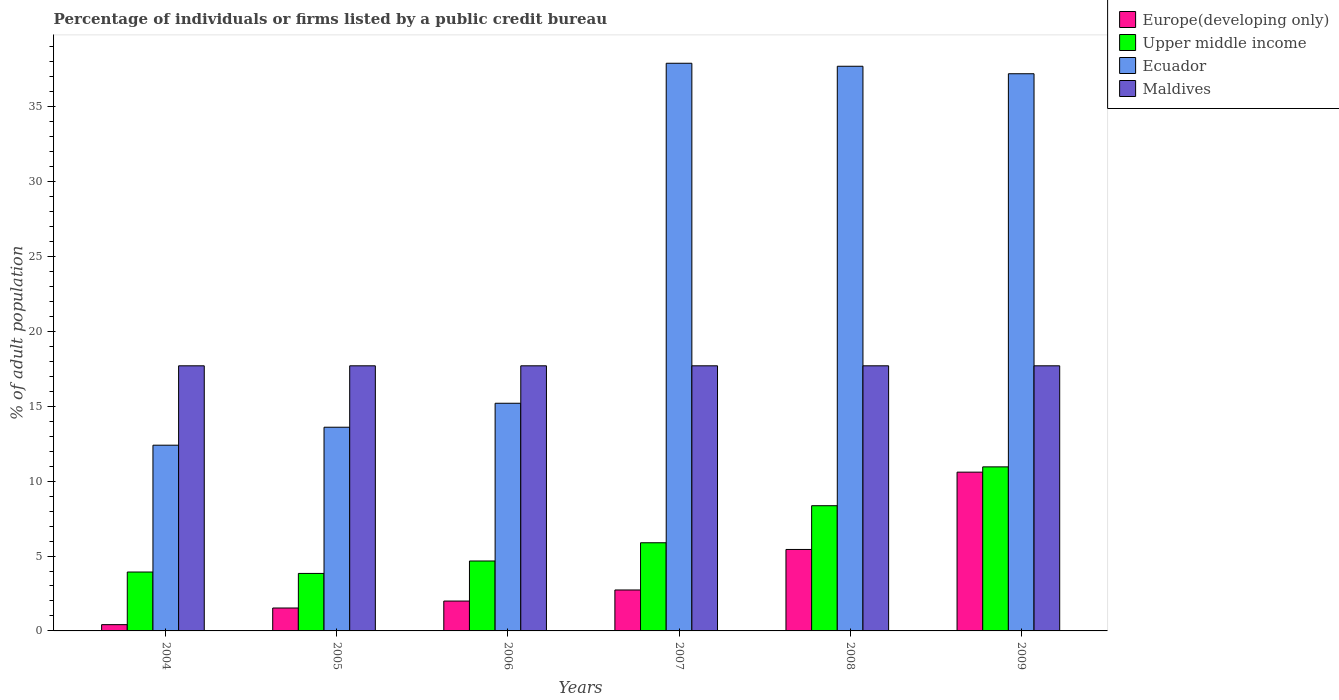How many different coloured bars are there?
Ensure brevity in your answer.  4. How many groups of bars are there?
Offer a very short reply. 6. Are the number of bars per tick equal to the number of legend labels?
Provide a succinct answer. Yes. Are the number of bars on each tick of the X-axis equal?
Your answer should be compact. Yes. What is the percentage of population listed by a public credit bureau in Upper middle income in 2008?
Give a very brief answer. 8.36. Across all years, what is the minimum percentage of population listed by a public credit bureau in Ecuador?
Keep it short and to the point. 12.4. In which year was the percentage of population listed by a public credit bureau in Europe(developing only) maximum?
Make the answer very short. 2009. What is the total percentage of population listed by a public credit bureau in Europe(developing only) in the graph?
Provide a short and direct response. 22.71. What is the difference between the percentage of population listed by a public credit bureau in Upper middle income in 2006 and that in 2007?
Offer a very short reply. -1.22. What is the difference between the percentage of population listed by a public credit bureau in Europe(developing only) in 2007 and the percentage of population listed by a public credit bureau in Ecuador in 2009?
Provide a succinct answer. -34.47. What is the average percentage of population listed by a public credit bureau in Upper middle income per year?
Offer a very short reply. 6.27. In the year 2008, what is the difference between the percentage of population listed by a public credit bureau in Upper middle income and percentage of population listed by a public credit bureau in Europe(developing only)?
Make the answer very short. 2.92. In how many years, is the percentage of population listed by a public credit bureau in Upper middle income greater than 32 %?
Make the answer very short. 0. What is the ratio of the percentage of population listed by a public credit bureau in Ecuador in 2006 to that in 2009?
Your answer should be compact. 0.41. Is the percentage of population listed by a public credit bureau in Ecuador in 2007 less than that in 2009?
Make the answer very short. No. Is the difference between the percentage of population listed by a public credit bureau in Upper middle income in 2007 and 2009 greater than the difference between the percentage of population listed by a public credit bureau in Europe(developing only) in 2007 and 2009?
Keep it short and to the point. Yes. What is the difference between the highest and the second highest percentage of population listed by a public credit bureau in Ecuador?
Provide a succinct answer. 0.2. What is the difference between the highest and the lowest percentage of population listed by a public credit bureau in Upper middle income?
Ensure brevity in your answer.  7.11. In how many years, is the percentage of population listed by a public credit bureau in Ecuador greater than the average percentage of population listed by a public credit bureau in Ecuador taken over all years?
Your answer should be very brief. 3. Is it the case that in every year, the sum of the percentage of population listed by a public credit bureau in Upper middle income and percentage of population listed by a public credit bureau in Europe(developing only) is greater than the sum of percentage of population listed by a public credit bureau in Maldives and percentage of population listed by a public credit bureau in Ecuador?
Your response must be concise. No. What does the 3rd bar from the left in 2009 represents?
Your answer should be very brief. Ecuador. What does the 2nd bar from the right in 2005 represents?
Your answer should be very brief. Ecuador. Is it the case that in every year, the sum of the percentage of population listed by a public credit bureau in Maldives and percentage of population listed by a public credit bureau in Ecuador is greater than the percentage of population listed by a public credit bureau in Europe(developing only)?
Your answer should be very brief. Yes. How many bars are there?
Your answer should be very brief. 24. Are all the bars in the graph horizontal?
Your answer should be very brief. No. How many years are there in the graph?
Ensure brevity in your answer.  6. Does the graph contain grids?
Make the answer very short. No. How are the legend labels stacked?
Ensure brevity in your answer.  Vertical. What is the title of the graph?
Offer a very short reply. Percentage of individuals or firms listed by a public credit bureau. What is the label or title of the X-axis?
Your answer should be very brief. Years. What is the label or title of the Y-axis?
Make the answer very short. % of adult population. What is the % of adult population in Europe(developing only) in 2004?
Provide a succinct answer. 0.42. What is the % of adult population in Upper middle income in 2004?
Make the answer very short. 3.93. What is the % of adult population in Maldives in 2004?
Provide a short and direct response. 17.7. What is the % of adult population of Europe(developing only) in 2005?
Keep it short and to the point. 1.53. What is the % of adult population in Upper middle income in 2005?
Provide a short and direct response. 3.84. What is the % of adult population of Ecuador in 2005?
Provide a short and direct response. 13.6. What is the % of adult population of Europe(developing only) in 2006?
Ensure brevity in your answer.  1.99. What is the % of adult population of Upper middle income in 2006?
Your answer should be compact. 4.67. What is the % of adult population of Ecuador in 2006?
Ensure brevity in your answer.  15.2. What is the % of adult population of Maldives in 2006?
Your answer should be very brief. 17.7. What is the % of adult population in Europe(developing only) in 2007?
Keep it short and to the point. 2.73. What is the % of adult population of Upper middle income in 2007?
Your answer should be very brief. 5.89. What is the % of adult population in Ecuador in 2007?
Ensure brevity in your answer.  37.9. What is the % of adult population in Europe(developing only) in 2008?
Provide a succinct answer. 5.44. What is the % of adult population of Upper middle income in 2008?
Give a very brief answer. 8.36. What is the % of adult population in Ecuador in 2008?
Keep it short and to the point. 37.7. What is the % of adult population of Upper middle income in 2009?
Provide a succinct answer. 10.95. What is the % of adult population in Ecuador in 2009?
Provide a succinct answer. 37.2. What is the % of adult population of Maldives in 2009?
Offer a very short reply. 17.7. Across all years, what is the maximum % of adult population in Europe(developing only)?
Your answer should be very brief. 10.6. Across all years, what is the maximum % of adult population in Upper middle income?
Provide a succinct answer. 10.95. Across all years, what is the maximum % of adult population in Ecuador?
Your answer should be very brief. 37.9. Across all years, what is the maximum % of adult population of Maldives?
Offer a very short reply. 17.7. Across all years, what is the minimum % of adult population in Europe(developing only)?
Your answer should be very brief. 0.42. Across all years, what is the minimum % of adult population in Upper middle income?
Your answer should be compact. 3.84. Across all years, what is the minimum % of adult population in Ecuador?
Your response must be concise. 12.4. What is the total % of adult population in Europe(developing only) in the graph?
Ensure brevity in your answer.  22.71. What is the total % of adult population in Upper middle income in the graph?
Provide a short and direct response. 37.64. What is the total % of adult population in Ecuador in the graph?
Make the answer very short. 154. What is the total % of adult population in Maldives in the graph?
Offer a very short reply. 106.2. What is the difference between the % of adult population in Europe(developing only) in 2004 and that in 2005?
Offer a very short reply. -1.11. What is the difference between the % of adult population in Upper middle income in 2004 and that in 2005?
Ensure brevity in your answer.  0.09. What is the difference between the % of adult population in Ecuador in 2004 and that in 2005?
Give a very brief answer. -1.2. What is the difference between the % of adult population in Maldives in 2004 and that in 2005?
Your response must be concise. 0. What is the difference between the % of adult population in Europe(developing only) in 2004 and that in 2006?
Keep it short and to the point. -1.58. What is the difference between the % of adult population of Upper middle income in 2004 and that in 2006?
Provide a succinct answer. -0.74. What is the difference between the % of adult population of Ecuador in 2004 and that in 2006?
Give a very brief answer. -2.8. What is the difference between the % of adult population of Europe(developing only) in 2004 and that in 2007?
Offer a terse response. -2.31. What is the difference between the % of adult population in Upper middle income in 2004 and that in 2007?
Provide a short and direct response. -1.95. What is the difference between the % of adult population in Ecuador in 2004 and that in 2007?
Give a very brief answer. -25.5. What is the difference between the % of adult population in Europe(developing only) in 2004 and that in 2008?
Offer a very short reply. -5.02. What is the difference between the % of adult population in Upper middle income in 2004 and that in 2008?
Provide a short and direct response. -4.43. What is the difference between the % of adult population in Ecuador in 2004 and that in 2008?
Offer a very short reply. -25.3. What is the difference between the % of adult population in Maldives in 2004 and that in 2008?
Give a very brief answer. 0. What is the difference between the % of adult population of Europe(developing only) in 2004 and that in 2009?
Provide a short and direct response. -10.18. What is the difference between the % of adult population in Upper middle income in 2004 and that in 2009?
Provide a succinct answer. -7.02. What is the difference between the % of adult population of Ecuador in 2004 and that in 2009?
Provide a short and direct response. -24.8. What is the difference between the % of adult population in Europe(developing only) in 2005 and that in 2006?
Offer a terse response. -0.47. What is the difference between the % of adult population in Upper middle income in 2005 and that in 2006?
Ensure brevity in your answer.  -0.83. What is the difference between the % of adult population in Maldives in 2005 and that in 2006?
Make the answer very short. 0. What is the difference between the % of adult population in Europe(developing only) in 2005 and that in 2007?
Your answer should be compact. -1.2. What is the difference between the % of adult population in Upper middle income in 2005 and that in 2007?
Ensure brevity in your answer.  -2.05. What is the difference between the % of adult population of Ecuador in 2005 and that in 2007?
Provide a succinct answer. -24.3. What is the difference between the % of adult population in Europe(developing only) in 2005 and that in 2008?
Make the answer very short. -3.91. What is the difference between the % of adult population of Upper middle income in 2005 and that in 2008?
Ensure brevity in your answer.  -4.52. What is the difference between the % of adult population of Ecuador in 2005 and that in 2008?
Make the answer very short. -24.1. What is the difference between the % of adult population of Maldives in 2005 and that in 2008?
Make the answer very short. 0. What is the difference between the % of adult population in Europe(developing only) in 2005 and that in 2009?
Your response must be concise. -9.07. What is the difference between the % of adult population in Upper middle income in 2005 and that in 2009?
Give a very brief answer. -7.11. What is the difference between the % of adult population in Ecuador in 2005 and that in 2009?
Give a very brief answer. -23.6. What is the difference between the % of adult population in Maldives in 2005 and that in 2009?
Keep it short and to the point. 0. What is the difference between the % of adult population in Europe(developing only) in 2006 and that in 2007?
Ensure brevity in your answer.  -0.74. What is the difference between the % of adult population of Upper middle income in 2006 and that in 2007?
Give a very brief answer. -1.22. What is the difference between the % of adult population in Ecuador in 2006 and that in 2007?
Provide a succinct answer. -22.7. What is the difference between the % of adult population in Europe(developing only) in 2006 and that in 2008?
Ensure brevity in your answer.  -3.44. What is the difference between the % of adult population in Upper middle income in 2006 and that in 2008?
Keep it short and to the point. -3.69. What is the difference between the % of adult population in Ecuador in 2006 and that in 2008?
Your answer should be very brief. -22.5. What is the difference between the % of adult population in Europe(developing only) in 2006 and that in 2009?
Offer a very short reply. -8.61. What is the difference between the % of adult population of Upper middle income in 2006 and that in 2009?
Give a very brief answer. -6.28. What is the difference between the % of adult population of Ecuador in 2006 and that in 2009?
Your answer should be compact. -22. What is the difference between the % of adult population of Maldives in 2006 and that in 2009?
Your response must be concise. 0. What is the difference between the % of adult population in Europe(developing only) in 2007 and that in 2008?
Your response must be concise. -2.71. What is the difference between the % of adult population of Upper middle income in 2007 and that in 2008?
Ensure brevity in your answer.  -2.47. What is the difference between the % of adult population of Ecuador in 2007 and that in 2008?
Provide a succinct answer. 0.2. What is the difference between the % of adult population of Europe(developing only) in 2007 and that in 2009?
Your response must be concise. -7.87. What is the difference between the % of adult population in Upper middle income in 2007 and that in 2009?
Your answer should be compact. -5.07. What is the difference between the % of adult population in Europe(developing only) in 2008 and that in 2009?
Offer a very short reply. -5.16. What is the difference between the % of adult population of Upper middle income in 2008 and that in 2009?
Make the answer very short. -2.59. What is the difference between the % of adult population in Maldives in 2008 and that in 2009?
Offer a very short reply. 0. What is the difference between the % of adult population of Europe(developing only) in 2004 and the % of adult population of Upper middle income in 2005?
Ensure brevity in your answer.  -3.42. What is the difference between the % of adult population in Europe(developing only) in 2004 and the % of adult population in Ecuador in 2005?
Your response must be concise. -13.18. What is the difference between the % of adult population of Europe(developing only) in 2004 and the % of adult population of Maldives in 2005?
Your response must be concise. -17.28. What is the difference between the % of adult population in Upper middle income in 2004 and the % of adult population in Ecuador in 2005?
Keep it short and to the point. -9.67. What is the difference between the % of adult population of Upper middle income in 2004 and the % of adult population of Maldives in 2005?
Your answer should be very brief. -13.77. What is the difference between the % of adult population in Ecuador in 2004 and the % of adult population in Maldives in 2005?
Make the answer very short. -5.3. What is the difference between the % of adult population of Europe(developing only) in 2004 and the % of adult population of Upper middle income in 2006?
Your answer should be very brief. -4.25. What is the difference between the % of adult population in Europe(developing only) in 2004 and the % of adult population in Ecuador in 2006?
Offer a very short reply. -14.78. What is the difference between the % of adult population in Europe(developing only) in 2004 and the % of adult population in Maldives in 2006?
Provide a short and direct response. -17.28. What is the difference between the % of adult population of Upper middle income in 2004 and the % of adult population of Ecuador in 2006?
Your answer should be very brief. -11.27. What is the difference between the % of adult population of Upper middle income in 2004 and the % of adult population of Maldives in 2006?
Give a very brief answer. -13.77. What is the difference between the % of adult population of Europe(developing only) in 2004 and the % of adult population of Upper middle income in 2007?
Your answer should be compact. -5.47. What is the difference between the % of adult population of Europe(developing only) in 2004 and the % of adult population of Ecuador in 2007?
Provide a short and direct response. -37.48. What is the difference between the % of adult population in Europe(developing only) in 2004 and the % of adult population in Maldives in 2007?
Your answer should be compact. -17.28. What is the difference between the % of adult population of Upper middle income in 2004 and the % of adult population of Ecuador in 2007?
Offer a terse response. -33.97. What is the difference between the % of adult population in Upper middle income in 2004 and the % of adult population in Maldives in 2007?
Offer a very short reply. -13.77. What is the difference between the % of adult population in Ecuador in 2004 and the % of adult population in Maldives in 2007?
Offer a terse response. -5.3. What is the difference between the % of adult population of Europe(developing only) in 2004 and the % of adult population of Upper middle income in 2008?
Ensure brevity in your answer.  -7.94. What is the difference between the % of adult population in Europe(developing only) in 2004 and the % of adult population in Ecuador in 2008?
Provide a short and direct response. -37.28. What is the difference between the % of adult population in Europe(developing only) in 2004 and the % of adult population in Maldives in 2008?
Ensure brevity in your answer.  -17.28. What is the difference between the % of adult population of Upper middle income in 2004 and the % of adult population of Ecuador in 2008?
Provide a succinct answer. -33.77. What is the difference between the % of adult population of Upper middle income in 2004 and the % of adult population of Maldives in 2008?
Make the answer very short. -13.77. What is the difference between the % of adult population of Europe(developing only) in 2004 and the % of adult population of Upper middle income in 2009?
Give a very brief answer. -10.53. What is the difference between the % of adult population in Europe(developing only) in 2004 and the % of adult population in Ecuador in 2009?
Offer a terse response. -36.78. What is the difference between the % of adult population of Europe(developing only) in 2004 and the % of adult population of Maldives in 2009?
Your response must be concise. -17.28. What is the difference between the % of adult population in Upper middle income in 2004 and the % of adult population in Ecuador in 2009?
Your answer should be compact. -33.27. What is the difference between the % of adult population in Upper middle income in 2004 and the % of adult population in Maldives in 2009?
Offer a very short reply. -13.77. What is the difference between the % of adult population of Ecuador in 2004 and the % of adult population of Maldives in 2009?
Provide a succinct answer. -5.3. What is the difference between the % of adult population in Europe(developing only) in 2005 and the % of adult population in Upper middle income in 2006?
Offer a terse response. -3.14. What is the difference between the % of adult population of Europe(developing only) in 2005 and the % of adult population of Ecuador in 2006?
Ensure brevity in your answer.  -13.67. What is the difference between the % of adult population of Europe(developing only) in 2005 and the % of adult population of Maldives in 2006?
Provide a succinct answer. -16.17. What is the difference between the % of adult population in Upper middle income in 2005 and the % of adult population in Ecuador in 2006?
Give a very brief answer. -11.36. What is the difference between the % of adult population in Upper middle income in 2005 and the % of adult population in Maldives in 2006?
Provide a short and direct response. -13.86. What is the difference between the % of adult population of Ecuador in 2005 and the % of adult population of Maldives in 2006?
Offer a terse response. -4.1. What is the difference between the % of adult population of Europe(developing only) in 2005 and the % of adult population of Upper middle income in 2007?
Your answer should be compact. -4.36. What is the difference between the % of adult population in Europe(developing only) in 2005 and the % of adult population in Ecuador in 2007?
Offer a terse response. -36.37. What is the difference between the % of adult population of Europe(developing only) in 2005 and the % of adult population of Maldives in 2007?
Ensure brevity in your answer.  -16.17. What is the difference between the % of adult population in Upper middle income in 2005 and the % of adult population in Ecuador in 2007?
Ensure brevity in your answer.  -34.06. What is the difference between the % of adult population in Upper middle income in 2005 and the % of adult population in Maldives in 2007?
Keep it short and to the point. -13.86. What is the difference between the % of adult population in Europe(developing only) in 2005 and the % of adult population in Upper middle income in 2008?
Keep it short and to the point. -6.83. What is the difference between the % of adult population of Europe(developing only) in 2005 and the % of adult population of Ecuador in 2008?
Give a very brief answer. -36.17. What is the difference between the % of adult population in Europe(developing only) in 2005 and the % of adult population in Maldives in 2008?
Ensure brevity in your answer.  -16.17. What is the difference between the % of adult population of Upper middle income in 2005 and the % of adult population of Ecuador in 2008?
Provide a succinct answer. -33.86. What is the difference between the % of adult population of Upper middle income in 2005 and the % of adult population of Maldives in 2008?
Your answer should be compact. -13.86. What is the difference between the % of adult population in Ecuador in 2005 and the % of adult population in Maldives in 2008?
Make the answer very short. -4.1. What is the difference between the % of adult population of Europe(developing only) in 2005 and the % of adult population of Upper middle income in 2009?
Ensure brevity in your answer.  -9.42. What is the difference between the % of adult population of Europe(developing only) in 2005 and the % of adult population of Ecuador in 2009?
Offer a terse response. -35.67. What is the difference between the % of adult population in Europe(developing only) in 2005 and the % of adult population in Maldives in 2009?
Provide a succinct answer. -16.17. What is the difference between the % of adult population of Upper middle income in 2005 and the % of adult population of Ecuador in 2009?
Make the answer very short. -33.36. What is the difference between the % of adult population of Upper middle income in 2005 and the % of adult population of Maldives in 2009?
Keep it short and to the point. -13.86. What is the difference between the % of adult population of Ecuador in 2005 and the % of adult population of Maldives in 2009?
Offer a terse response. -4.1. What is the difference between the % of adult population of Europe(developing only) in 2006 and the % of adult population of Upper middle income in 2007?
Give a very brief answer. -3.89. What is the difference between the % of adult population of Europe(developing only) in 2006 and the % of adult population of Ecuador in 2007?
Ensure brevity in your answer.  -35.91. What is the difference between the % of adult population of Europe(developing only) in 2006 and the % of adult population of Maldives in 2007?
Ensure brevity in your answer.  -15.71. What is the difference between the % of adult population of Upper middle income in 2006 and the % of adult population of Ecuador in 2007?
Your answer should be compact. -33.23. What is the difference between the % of adult population of Upper middle income in 2006 and the % of adult population of Maldives in 2007?
Make the answer very short. -13.03. What is the difference between the % of adult population of Europe(developing only) in 2006 and the % of adult population of Upper middle income in 2008?
Ensure brevity in your answer.  -6.37. What is the difference between the % of adult population of Europe(developing only) in 2006 and the % of adult population of Ecuador in 2008?
Provide a succinct answer. -35.71. What is the difference between the % of adult population of Europe(developing only) in 2006 and the % of adult population of Maldives in 2008?
Your response must be concise. -15.71. What is the difference between the % of adult population in Upper middle income in 2006 and the % of adult population in Ecuador in 2008?
Keep it short and to the point. -33.03. What is the difference between the % of adult population of Upper middle income in 2006 and the % of adult population of Maldives in 2008?
Provide a short and direct response. -13.03. What is the difference between the % of adult population of Europe(developing only) in 2006 and the % of adult population of Upper middle income in 2009?
Make the answer very short. -8.96. What is the difference between the % of adult population of Europe(developing only) in 2006 and the % of adult population of Ecuador in 2009?
Offer a very short reply. -35.21. What is the difference between the % of adult population in Europe(developing only) in 2006 and the % of adult population in Maldives in 2009?
Offer a terse response. -15.71. What is the difference between the % of adult population of Upper middle income in 2006 and the % of adult population of Ecuador in 2009?
Your answer should be compact. -32.53. What is the difference between the % of adult population of Upper middle income in 2006 and the % of adult population of Maldives in 2009?
Your answer should be compact. -13.03. What is the difference between the % of adult population in Ecuador in 2006 and the % of adult population in Maldives in 2009?
Your answer should be compact. -2.5. What is the difference between the % of adult population in Europe(developing only) in 2007 and the % of adult population in Upper middle income in 2008?
Your answer should be very brief. -5.63. What is the difference between the % of adult population in Europe(developing only) in 2007 and the % of adult population in Ecuador in 2008?
Your response must be concise. -34.97. What is the difference between the % of adult population in Europe(developing only) in 2007 and the % of adult population in Maldives in 2008?
Ensure brevity in your answer.  -14.97. What is the difference between the % of adult population of Upper middle income in 2007 and the % of adult population of Ecuador in 2008?
Your answer should be compact. -31.81. What is the difference between the % of adult population of Upper middle income in 2007 and the % of adult population of Maldives in 2008?
Provide a short and direct response. -11.81. What is the difference between the % of adult population of Ecuador in 2007 and the % of adult population of Maldives in 2008?
Your answer should be very brief. 20.2. What is the difference between the % of adult population of Europe(developing only) in 2007 and the % of adult population of Upper middle income in 2009?
Offer a very short reply. -8.22. What is the difference between the % of adult population in Europe(developing only) in 2007 and the % of adult population in Ecuador in 2009?
Make the answer very short. -34.47. What is the difference between the % of adult population of Europe(developing only) in 2007 and the % of adult population of Maldives in 2009?
Your response must be concise. -14.97. What is the difference between the % of adult population of Upper middle income in 2007 and the % of adult population of Ecuador in 2009?
Offer a very short reply. -31.31. What is the difference between the % of adult population in Upper middle income in 2007 and the % of adult population in Maldives in 2009?
Keep it short and to the point. -11.81. What is the difference between the % of adult population in Ecuador in 2007 and the % of adult population in Maldives in 2009?
Provide a succinct answer. 20.2. What is the difference between the % of adult population in Europe(developing only) in 2008 and the % of adult population in Upper middle income in 2009?
Keep it short and to the point. -5.51. What is the difference between the % of adult population of Europe(developing only) in 2008 and the % of adult population of Ecuador in 2009?
Give a very brief answer. -31.76. What is the difference between the % of adult population in Europe(developing only) in 2008 and the % of adult population in Maldives in 2009?
Your answer should be compact. -12.26. What is the difference between the % of adult population in Upper middle income in 2008 and the % of adult population in Ecuador in 2009?
Your answer should be very brief. -28.84. What is the difference between the % of adult population of Upper middle income in 2008 and the % of adult population of Maldives in 2009?
Offer a very short reply. -9.34. What is the average % of adult population in Europe(developing only) per year?
Make the answer very short. 3.79. What is the average % of adult population in Upper middle income per year?
Provide a short and direct response. 6.27. What is the average % of adult population of Ecuador per year?
Give a very brief answer. 25.67. What is the average % of adult population of Maldives per year?
Provide a short and direct response. 17.7. In the year 2004, what is the difference between the % of adult population in Europe(developing only) and % of adult population in Upper middle income?
Offer a terse response. -3.51. In the year 2004, what is the difference between the % of adult population of Europe(developing only) and % of adult population of Ecuador?
Provide a short and direct response. -11.98. In the year 2004, what is the difference between the % of adult population in Europe(developing only) and % of adult population in Maldives?
Your response must be concise. -17.28. In the year 2004, what is the difference between the % of adult population in Upper middle income and % of adult population in Ecuador?
Your response must be concise. -8.47. In the year 2004, what is the difference between the % of adult population in Upper middle income and % of adult population in Maldives?
Provide a succinct answer. -13.77. In the year 2005, what is the difference between the % of adult population of Europe(developing only) and % of adult population of Upper middle income?
Keep it short and to the point. -2.31. In the year 2005, what is the difference between the % of adult population in Europe(developing only) and % of adult population in Ecuador?
Ensure brevity in your answer.  -12.07. In the year 2005, what is the difference between the % of adult population in Europe(developing only) and % of adult population in Maldives?
Make the answer very short. -16.17. In the year 2005, what is the difference between the % of adult population in Upper middle income and % of adult population in Ecuador?
Offer a terse response. -9.76. In the year 2005, what is the difference between the % of adult population in Upper middle income and % of adult population in Maldives?
Provide a short and direct response. -13.86. In the year 2005, what is the difference between the % of adult population of Ecuador and % of adult population of Maldives?
Give a very brief answer. -4.1. In the year 2006, what is the difference between the % of adult population in Europe(developing only) and % of adult population in Upper middle income?
Ensure brevity in your answer.  -2.67. In the year 2006, what is the difference between the % of adult population in Europe(developing only) and % of adult population in Ecuador?
Your answer should be very brief. -13.21. In the year 2006, what is the difference between the % of adult population of Europe(developing only) and % of adult population of Maldives?
Give a very brief answer. -15.71. In the year 2006, what is the difference between the % of adult population in Upper middle income and % of adult population in Ecuador?
Offer a terse response. -10.53. In the year 2006, what is the difference between the % of adult population in Upper middle income and % of adult population in Maldives?
Provide a short and direct response. -13.03. In the year 2006, what is the difference between the % of adult population of Ecuador and % of adult population of Maldives?
Keep it short and to the point. -2.5. In the year 2007, what is the difference between the % of adult population of Europe(developing only) and % of adult population of Upper middle income?
Ensure brevity in your answer.  -3.15. In the year 2007, what is the difference between the % of adult population in Europe(developing only) and % of adult population in Ecuador?
Your response must be concise. -35.17. In the year 2007, what is the difference between the % of adult population of Europe(developing only) and % of adult population of Maldives?
Your response must be concise. -14.97. In the year 2007, what is the difference between the % of adult population of Upper middle income and % of adult population of Ecuador?
Give a very brief answer. -32.01. In the year 2007, what is the difference between the % of adult population of Upper middle income and % of adult population of Maldives?
Provide a succinct answer. -11.81. In the year 2007, what is the difference between the % of adult population in Ecuador and % of adult population in Maldives?
Your response must be concise. 20.2. In the year 2008, what is the difference between the % of adult population in Europe(developing only) and % of adult population in Upper middle income?
Give a very brief answer. -2.92. In the year 2008, what is the difference between the % of adult population in Europe(developing only) and % of adult population in Ecuador?
Your answer should be compact. -32.26. In the year 2008, what is the difference between the % of adult population of Europe(developing only) and % of adult population of Maldives?
Your answer should be compact. -12.26. In the year 2008, what is the difference between the % of adult population of Upper middle income and % of adult population of Ecuador?
Ensure brevity in your answer.  -29.34. In the year 2008, what is the difference between the % of adult population of Upper middle income and % of adult population of Maldives?
Your answer should be compact. -9.34. In the year 2008, what is the difference between the % of adult population of Ecuador and % of adult population of Maldives?
Ensure brevity in your answer.  20. In the year 2009, what is the difference between the % of adult population in Europe(developing only) and % of adult population in Upper middle income?
Keep it short and to the point. -0.35. In the year 2009, what is the difference between the % of adult population of Europe(developing only) and % of adult population of Ecuador?
Keep it short and to the point. -26.6. In the year 2009, what is the difference between the % of adult population of Europe(developing only) and % of adult population of Maldives?
Offer a terse response. -7.1. In the year 2009, what is the difference between the % of adult population in Upper middle income and % of adult population in Ecuador?
Your answer should be very brief. -26.25. In the year 2009, what is the difference between the % of adult population of Upper middle income and % of adult population of Maldives?
Ensure brevity in your answer.  -6.75. What is the ratio of the % of adult population in Europe(developing only) in 2004 to that in 2005?
Provide a succinct answer. 0.27. What is the ratio of the % of adult population of Upper middle income in 2004 to that in 2005?
Your answer should be compact. 1.02. What is the ratio of the % of adult population in Ecuador in 2004 to that in 2005?
Your answer should be very brief. 0.91. What is the ratio of the % of adult population in Maldives in 2004 to that in 2005?
Ensure brevity in your answer.  1. What is the ratio of the % of adult population in Europe(developing only) in 2004 to that in 2006?
Provide a short and direct response. 0.21. What is the ratio of the % of adult population of Upper middle income in 2004 to that in 2006?
Offer a terse response. 0.84. What is the ratio of the % of adult population of Ecuador in 2004 to that in 2006?
Make the answer very short. 0.82. What is the ratio of the % of adult population of Maldives in 2004 to that in 2006?
Give a very brief answer. 1. What is the ratio of the % of adult population of Europe(developing only) in 2004 to that in 2007?
Offer a terse response. 0.15. What is the ratio of the % of adult population of Upper middle income in 2004 to that in 2007?
Provide a short and direct response. 0.67. What is the ratio of the % of adult population of Ecuador in 2004 to that in 2007?
Your answer should be very brief. 0.33. What is the ratio of the % of adult population of Europe(developing only) in 2004 to that in 2008?
Your answer should be very brief. 0.08. What is the ratio of the % of adult population of Upper middle income in 2004 to that in 2008?
Make the answer very short. 0.47. What is the ratio of the % of adult population in Ecuador in 2004 to that in 2008?
Your answer should be compact. 0.33. What is the ratio of the % of adult population of Maldives in 2004 to that in 2008?
Ensure brevity in your answer.  1. What is the ratio of the % of adult population of Europe(developing only) in 2004 to that in 2009?
Ensure brevity in your answer.  0.04. What is the ratio of the % of adult population in Upper middle income in 2004 to that in 2009?
Your response must be concise. 0.36. What is the ratio of the % of adult population in Maldives in 2004 to that in 2009?
Give a very brief answer. 1. What is the ratio of the % of adult population of Europe(developing only) in 2005 to that in 2006?
Give a very brief answer. 0.77. What is the ratio of the % of adult population of Upper middle income in 2005 to that in 2006?
Offer a terse response. 0.82. What is the ratio of the % of adult population of Ecuador in 2005 to that in 2006?
Keep it short and to the point. 0.89. What is the ratio of the % of adult population in Europe(developing only) in 2005 to that in 2007?
Make the answer very short. 0.56. What is the ratio of the % of adult population of Upper middle income in 2005 to that in 2007?
Offer a terse response. 0.65. What is the ratio of the % of adult population of Ecuador in 2005 to that in 2007?
Provide a succinct answer. 0.36. What is the ratio of the % of adult population of Europe(developing only) in 2005 to that in 2008?
Provide a succinct answer. 0.28. What is the ratio of the % of adult population of Upper middle income in 2005 to that in 2008?
Your answer should be very brief. 0.46. What is the ratio of the % of adult population in Ecuador in 2005 to that in 2008?
Keep it short and to the point. 0.36. What is the ratio of the % of adult population in Europe(developing only) in 2005 to that in 2009?
Your response must be concise. 0.14. What is the ratio of the % of adult population in Upper middle income in 2005 to that in 2009?
Offer a very short reply. 0.35. What is the ratio of the % of adult population of Ecuador in 2005 to that in 2009?
Your answer should be compact. 0.37. What is the ratio of the % of adult population in Maldives in 2005 to that in 2009?
Provide a succinct answer. 1. What is the ratio of the % of adult population in Europe(developing only) in 2006 to that in 2007?
Offer a very short reply. 0.73. What is the ratio of the % of adult population of Upper middle income in 2006 to that in 2007?
Keep it short and to the point. 0.79. What is the ratio of the % of adult population in Ecuador in 2006 to that in 2007?
Give a very brief answer. 0.4. What is the ratio of the % of adult population in Europe(developing only) in 2006 to that in 2008?
Offer a very short reply. 0.37. What is the ratio of the % of adult population in Upper middle income in 2006 to that in 2008?
Provide a short and direct response. 0.56. What is the ratio of the % of adult population of Ecuador in 2006 to that in 2008?
Give a very brief answer. 0.4. What is the ratio of the % of adult population of Maldives in 2006 to that in 2008?
Keep it short and to the point. 1. What is the ratio of the % of adult population in Europe(developing only) in 2006 to that in 2009?
Keep it short and to the point. 0.19. What is the ratio of the % of adult population in Upper middle income in 2006 to that in 2009?
Offer a very short reply. 0.43. What is the ratio of the % of adult population in Ecuador in 2006 to that in 2009?
Give a very brief answer. 0.41. What is the ratio of the % of adult population of Europe(developing only) in 2007 to that in 2008?
Ensure brevity in your answer.  0.5. What is the ratio of the % of adult population in Upper middle income in 2007 to that in 2008?
Provide a short and direct response. 0.7. What is the ratio of the % of adult population of Maldives in 2007 to that in 2008?
Ensure brevity in your answer.  1. What is the ratio of the % of adult population in Europe(developing only) in 2007 to that in 2009?
Provide a short and direct response. 0.26. What is the ratio of the % of adult population of Upper middle income in 2007 to that in 2009?
Provide a short and direct response. 0.54. What is the ratio of the % of adult population of Ecuador in 2007 to that in 2009?
Provide a succinct answer. 1.02. What is the ratio of the % of adult population of Maldives in 2007 to that in 2009?
Offer a terse response. 1. What is the ratio of the % of adult population in Europe(developing only) in 2008 to that in 2009?
Give a very brief answer. 0.51. What is the ratio of the % of adult population of Upper middle income in 2008 to that in 2009?
Offer a terse response. 0.76. What is the ratio of the % of adult population in Ecuador in 2008 to that in 2009?
Provide a succinct answer. 1.01. What is the difference between the highest and the second highest % of adult population in Europe(developing only)?
Provide a succinct answer. 5.16. What is the difference between the highest and the second highest % of adult population in Upper middle income?
Your answer should be very brief. 2.59. What is the difference between the highest and the second highest % of adult population in Ecuador?
Provide a succinct answer. 0.2. What is the difference between the highest and the lowest % of adult population of Europe(developing only)?
Your response must be concise. 10.18. What is the difference between the highest and the lowest % of adult population of Upper middle income?
Ensure brevity in your answer.  7.11. 